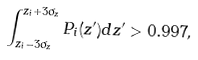Convert formula to latex. <formula><loc_0><loc_0><loc_500><loc_500>\int _ { z _ { i } - 3 \sigma _ { z } } ^ { z _ { i } + 3 \sigma _ { z } } P _ { i } ( z ^ { \prime } ) d z ^ { \prime } > 0 . 9 9 7 ,</formula> 